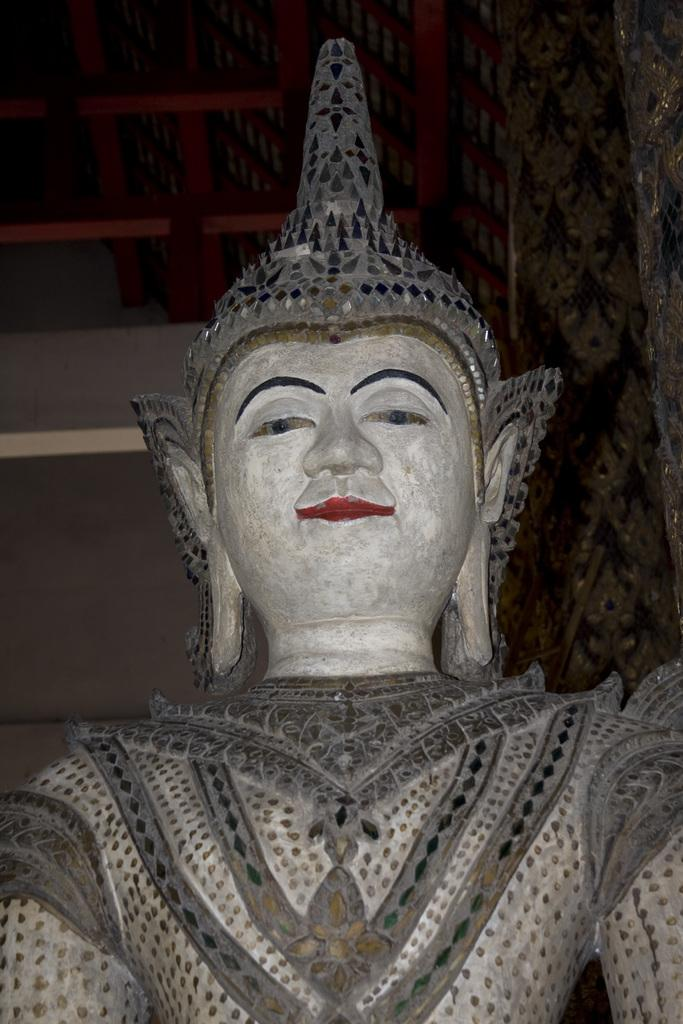What is the main subject of the image? There is a Buddha statue in the image. What is a notable feature of the Buddha statue? The Buddha statue has a crown. What can be seen in the background of the image? There is a ceiling visible in the background of the image. What is a characteristic of the ceiling? The ceiling has red color sticks. How many cacti are placed around the Buddha statue in the image? There are no cacti present in the image; it only features the Buddha statue with a crown and a ceiling with red color sticks in the background. 